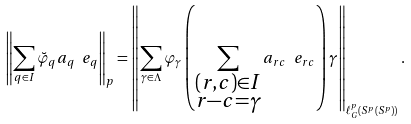Convert formula to latex. <formula><loc_0><loc_0><loc_500><loc_500>\left \| \sum _ { q \in I } \breve { \varphi } _ { q } a _ { q } \ e _ { q } \right \| _ { p } = \left \| \sum _ { \gamma \in \Lambda } \varphi _ { \gamma } \left ( \sum _ { \substack { ( r , c ) \in I \\ r - c = \gamma } } a _ { r c } \ e _ { r c } \right ) \gamma \right \| _ { \ell ^ { p } _ { G } ( S ^ { p } ( S ^ { p } ) ) } .</formula> 